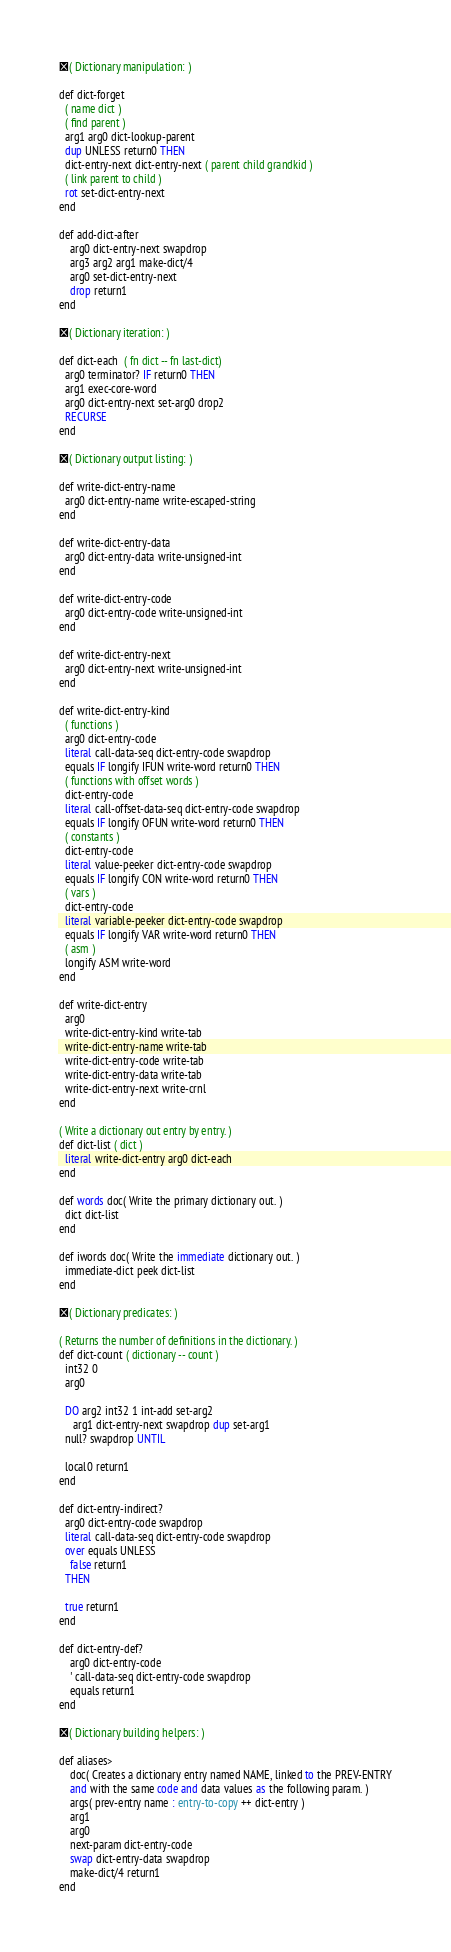Convert code to text. <code><loc_0><loc_0><loc_500><loc_500><_Forth_>( Dictionary manipulation: )

def dict-forget
  ( name dict )
  ( find parent )
  arg1 arg0 dict-lookup-parent
  dup UNLESS return0 THEN
  dict-entry-next dict-entry-next ( parent child grandkid )
  ( link parent to child )
  rot set-dict-entry-next
end

def add-dict-after
    arg0 dict-entry-next swapdrop
    arg3 arg2 arg1 make-dict/4
    arg0 set-dict-entry-next
    drop return1
end

( Dictionary iteration: )

def dict-each  ( fn dict -- fn last-dict)
  arg0 terminator? IF return0 THEN
  arg1 exec-core-word
  arg0 dict-entry-next set-arg0 drop2
  RECURSE
end

( Dictionary output listing: )

def write-dict-entry-name
  arg0 dict-entry-name write-escaped-string
end

def write-dict-entry-data
  arg0 dict-entry-data write-unsigned-int 
end

def write-dict-entry-code
  arg0 dict-entry-code write-unsigned-int 
end

def write-dict-entry-next
  arg0 dict-entry-next write-unsigned-int
end

def write-dict-entry-kind
  ( functions )
  arg0 dict-entry-code
  literal call-data-seq dict-entry-code swapdrop
  equals IF longify IFUN write-word return0 THEN
  ( functions with offset words )
  dict-entry-code
  literal call-offset-data-seq dict-entry-code swapdrop
  equals IF longify OFUN write-word return0 THEN
  ( constants )
  dict-entry-code 
  literal value-peeker dict-entry-code swapdrop
  equals IF longify CON write-word return0 THEN
  ( vars )
  dict-entry-code 
  literal variable-peeker dict-entry-code swapdrop
  equals IF longify VAR write-word return0 THEN
  ( asm )
  longify ASM write-word 
end

def write-dict-entry
  arg0
  write-dict-entry-kind write-tab 
  write-dict-entry-name write-tab 
  write-dict-entry-code write-tab
  write-dict-entry-data write-tab 
  write-dict-entry-next write-crnl 
end

( Write a dictionary out entry by entry. )
def dict-list ( dict )
  literal write-dict-entry arg0 dict-each 
end

def words doc( Write the primary dictionary out. )
  dict dict-list
end

def iwords doc( Write the immediate dictionary out. )
  immediate-dict peek dict-list
end

( Dictionary predicates: )

( Returns the number of definitions in the dictionary. )
def dict-count ( dictionary -- count )
  int32 0
  arg0
  
  DO arg2 int32 1 int-add set-arg2
     arg1 dict-entry-next swapdrop dup set-arg1
  null? swapdrop UNTIL

  local0 return1
end

def dict-entry-indirect?
  arg0 dict-entry-code swapdrop
  literal call-data-seq dict-entry-code swapdrop
  over equals UNLESS
    false return1
  THEN

  true return1
end

def dict-entry-def?
    arg0 dict-entry-code
    ' call-data-seq dict-entry-code swapdrop
    equals return1
end

( Dictionary building helpers: )

def aliases>
    doc( Creates a dictionary entry named NAME, linked to the PREV-ENTRY
    and with the same code and data values as the following param. )
    args( prev-entry name : entry-to-copy ++ dict-entry )
    arg1
    arg0
    next-param dict-entry-code
    swap dict-entry-data swapdrop
    make-dict/4 return1
end
</code> 